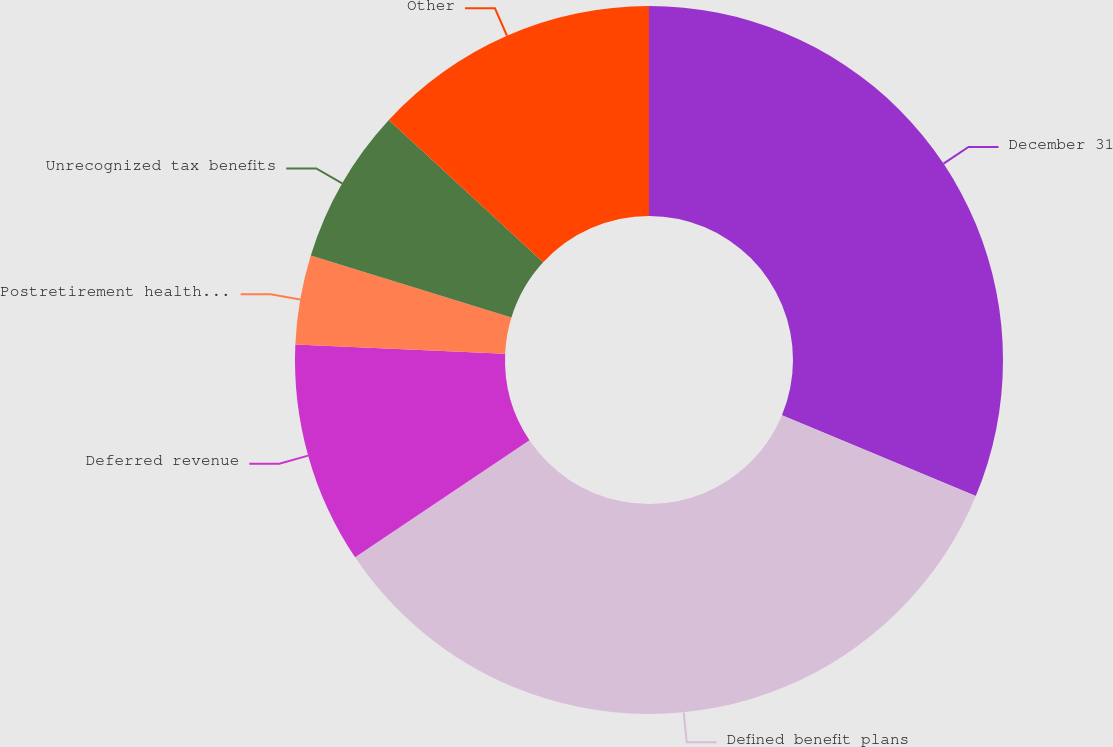Convert chart to OTSL. <chart><loc_0><loc_0><loc_500><loc_500><pie_chart><fcel>December 31<fcel>Defined benefit plans<fcel>Deferred revenue<fcel>Postretirement health care<fcel>Unrecognized tax benefits<fcel>Other<nl><fcel>31.28%<fcel>34.31%<fcel>10.11%<fcel>4.07%<fcel>7.09%<fcel>13.14%<nl></chart> 